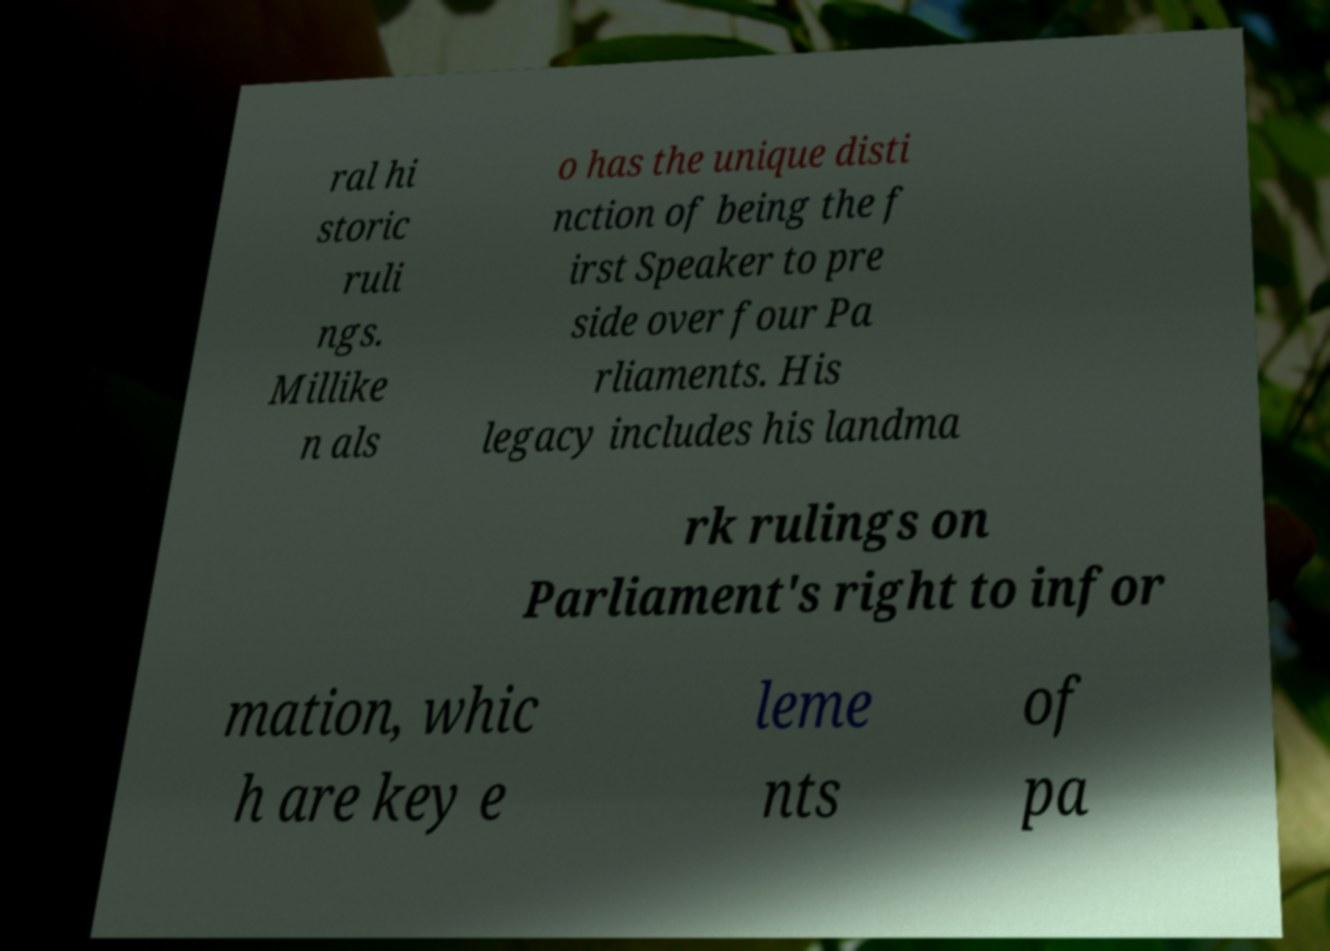Please identify and transcribe the text found in this image. ral hi storic ruli ngs. Millike n als o has the unique disti nction of being the f irst Speaker to pre side over four Pa rliaments. His legacy includes his landma rk rulings on Parliament's right to infor mation, whic h are key e leme nts of pa 